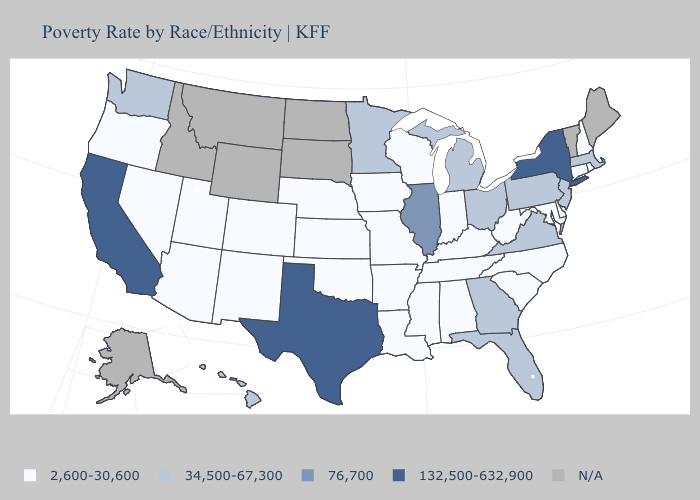Name the states that have a value in the range 34,500-67,300?
Write a very short answer. Florida, Georgia, Hawaii, Massachusetts, Michigan, Minnesota, New Jersey, Ohio, Pennsylvania, Virginia, Washington. What is the highest value in the South ?
Answer briefly. 132,500-632,900. What is the highest value in the West ?
Give a very brief answer. 132,500-632,900. Name the states that have a value in the range 2,600-30,600?
Quick response, please. Alabama, Arizona, Arkansas, Colorado, Connecticut, Delaware, Indiana, Iowa, Kansas, Kentucky, Louisiana, Maryland, Mississippi, Missouri, Nebraska, Nevada, New Hampshire, New Mexico, North Carolina, Oklahoma, Oregon, Rhode Island, South Carolina, Tennessee, Utah, West Virginia, Wisconsin. What is the lowest value in the USA?
Give a very brief answer. 2,600-30,600. Among the states that border Delaware , does Pennsylvania have the lowest value?
Be succinct. No. Among the states that border New York , which have the highest value?
Answer briefly. Massachusetts, New Jersey, Pennsylvania. Does New Jersey have the lowest value in the USA?
Write a very short answer. No. What is the value of West Virginia?
Concise answer only. 2,600-30,600. Does Florida have the highest value in the South?
Short answer required. No. What is the value of Maine?
Keep it brief. N/A. What is the value of Virginia?
Give a very brief answer. 34,500-67,300. Is the legend a continuous bar?
Give a very brief answer. No. Does the map have missing data?
Give a very brief answer. Yes. Does Texas have the highest value in the USA?
Be succinct. Yes. 